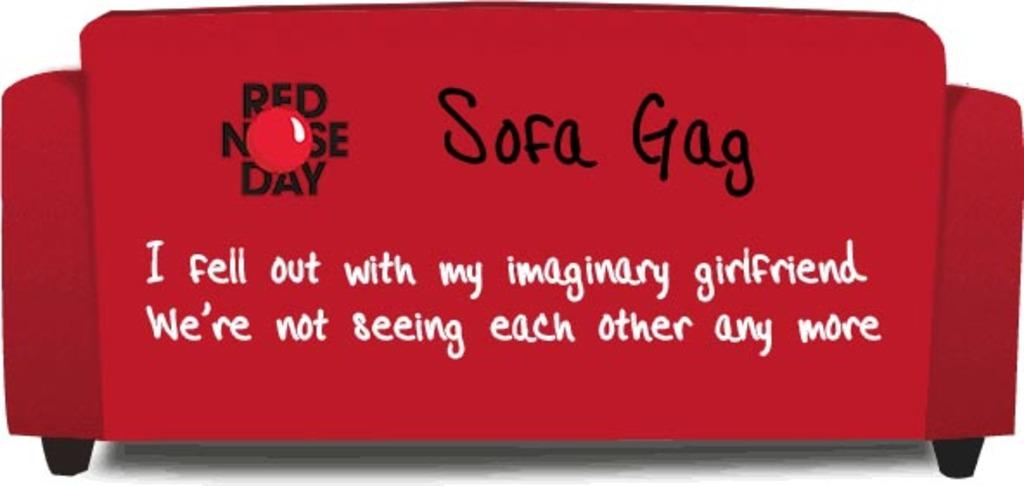What type of furniture is in the image? There is a red sofa in the image. Does the sofa have any unique characteristics? Yes, the sofa appears to be animated. Is there any writing on the sofa? Yes, there is text written on the sofa. What type of vessel is being used to transport the dogs in the image? There are no dogs or vessels present in the image; it features a red sofa with text. 